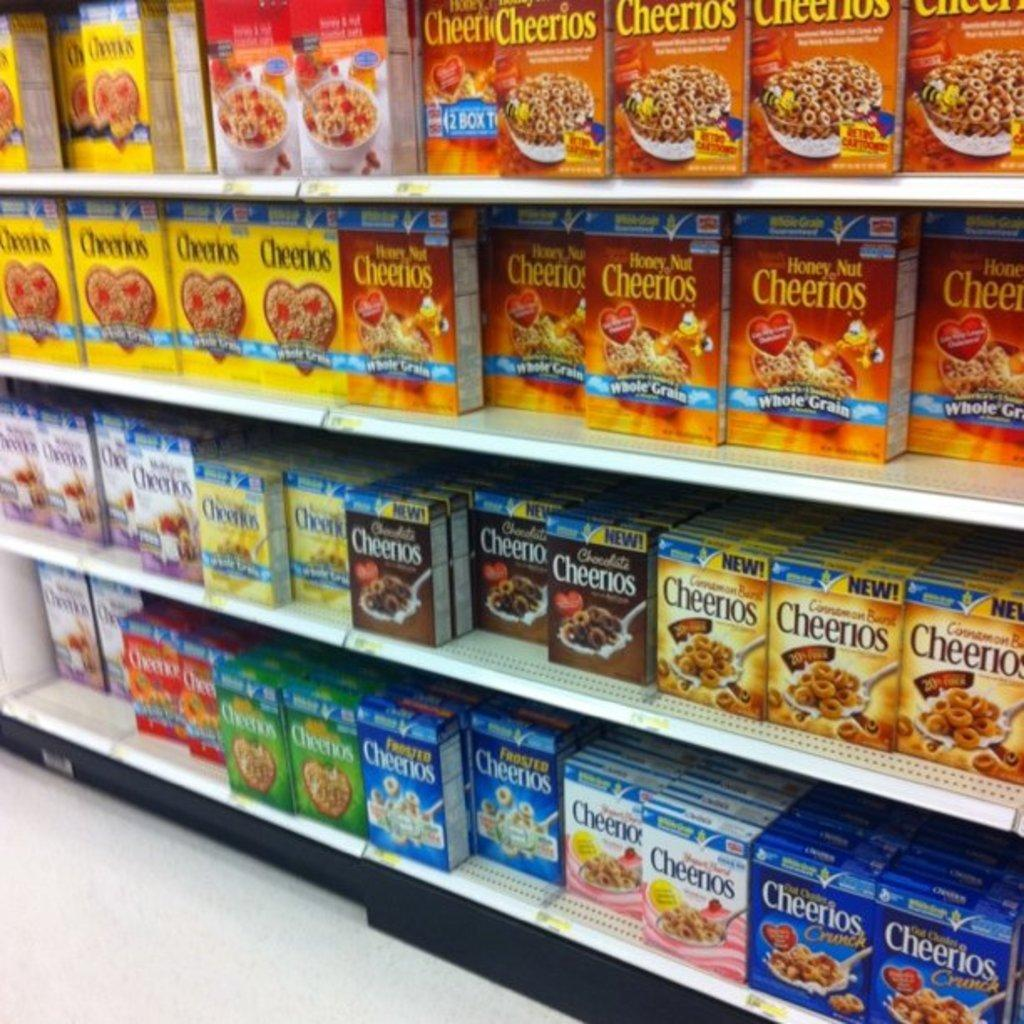<image>
Provide a brief description of the given image. A store shelf lined with Cheerios cerials of different flavors including Honey Nut, chocolate, and original. 